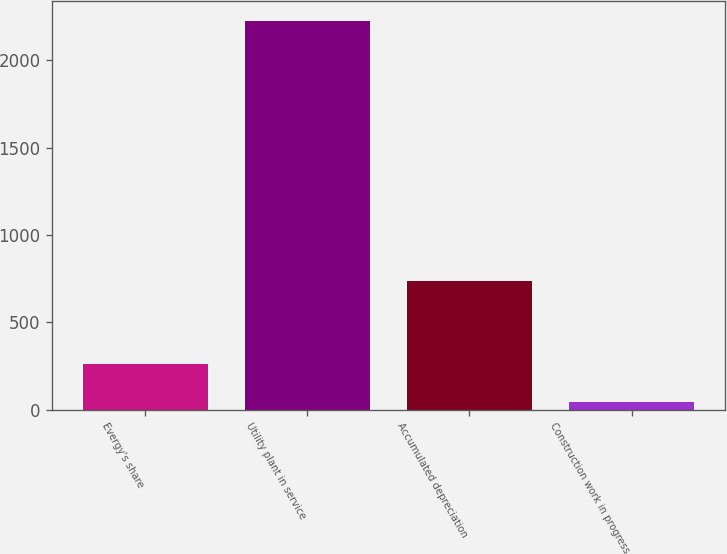Convert chart to OTSL. <chart><loc_0><loc_0><loc_500><loc_500><bar_chart><fcel>Evergy's share<fcel>Utility plant in service<fcel>Accumulated depreciation<fcel>Construction work in progress<nl><fcel>260.42<fcel>2228<fcel>737.1<fcel>41.8<nl></chart> 